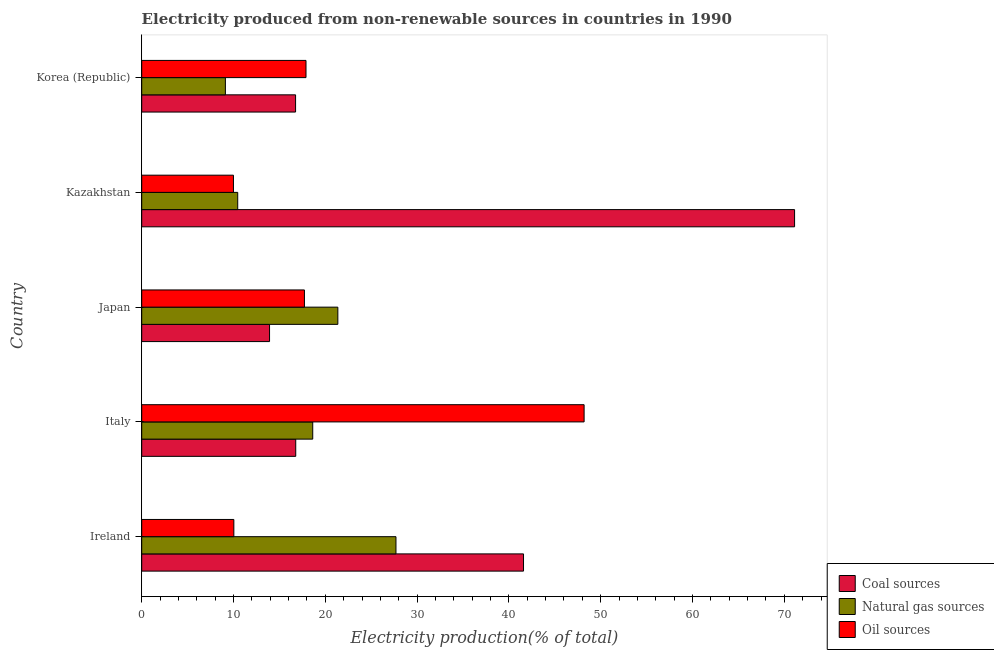How many bars are there on the 5th tick from the top?
Provide a succinct answer. 3. In how many cases, is the number of bars for a given country not equal to the number of legend labels?
Keep it short and to the point. 0. What is the percentage of electricity produced by oil sources in Korea (Republic)?
Offer a very short reply. 17.9. Across all countries, what is the maximum percentage of electricity produced by oil sources?
Your answer should be compact. 48.19. Across all countries, what is the minimum percentage of electricity produced by coal?
Your answer should be very brief. 13.92. In which country was the percentage of electricity produced by coal maximum?
Offer a terse response. Kazakhstan. What is the total percentage of electricity produced by natural gas in the graph?
Give a very brief answer. 87.26. What is the difference between the percentage of electricity produced by oil sources in Italy and that in Korea (Republic)?
Ensure brevity in your answer.  30.3. What is the difference between the percentage of electricity produced by natural gas in Japan and the percentage of electricity produced by coal in Italy?
Ensure brevity in your answer.  4.59. What is the average percentage of electricity produced by coal per country?
Make the answer very short. 32.03. What is the difference between the percentage of electricity produced by coal and percentage of electricity produced by natural gas in Ireland?
Offer a terse response. 13.89. Is the difference between the percentage of electricity produced by natural gas in Japan and Korea (Republic) greater than the difference between the percentage of electricity produced by coal in Japan and Korea (Republic)?
Provide a short and direct response. Yes. What is the difference between the highest and the second highest percentage of electricity produced by coal?
Make the answer very short. 29.53. What is the difference between the highest and the lowest percentage of electricity produced by natural gas?
Ensure brevity in your answer.  18.58. In how many countries, is the percentage of electricity produced by oil sources greater than the average percentage of electricity produced by oil sources taken over all countries?
Offer a terse response. 1. What does the 1st bar from the top in Kazakhstan represents?
Keep it short and to the point. Oil sources. What does the 2nd bar from the bottom in Italy represents?
Make the answer very short. Natural gas sources. What is the difference between two consecutive major ticks on the X-axis?
Make the answer very short. 10. Are the values on the major ticks of X-axis written in scientific E-notation?
Give a very brief answer. No. Where does the legend appear in the graph?
Your response must be concise. Bottom right. How many legend labels are there?
Your response must be concise. 3. What is the title of the graph?
Ensure brevity in your answer.  Electricity produced from non-renewable sources in countries in 1990. Does "Taxes on income" appear as one of the legend labels in the graph?
Your answer should be compact. No. What is the Electricity production(% of total) of Coal sources in Ireland?
Give a very brief answer. 41.59. What is the Electricity production(% of total) in Natural gas sources in Ireland?
Offer a very short reply. 27.7. What is the Electricity production(% of total) in Oil sources in Ireland?
Offer a terse response. 10.04. What is the Electricity production(% of total) of Coal sources in Italy?
Your answer should be compact. 16.78. What is the Electricity production(% of total) in Natural gas sources in Italy?
Your answer should be very brief. 18.63. What is the Electricity production(% of total) of Oil sources in Italy?
Your answer should be compact. 48.19. What is the Electricity production(% of total) in Coal sources in Japan?
Give a very brief answer. 13.92. What is the Electricity production(% of total) in Natural gas sources in Japan?
Provide a succinct answer. 21.36. What is the Electricity production(% of total) of Oil sources in Japan?
Your answer should be compact. 17.72. What is the Electricity production(% of total) in Coal sources in Kazakhstan?
Offer a terse response. 71.12. What is the Electricity production(% of total) in Natural gas sources in Kazakhstan?
Your answer should be very brief. 10.46. What is the Electricity production(% of total) in Oil sources in Kazakhstan?
Your answer should be very brief. 9.99. What is the Electricity production(% of total) in Coal sources in Korea (Republic)?
Your response must be concise. 16.76. What is the Electricity production(% of total) in Natural gas sources in Korea (Republic)?
Offer a terse response. 9.11. What is the Electricity production(% of total) in Oil sources in Korea (Republic)?
Provide a short and direct response. 17.9. Across all countries, what is the maximum Electricity production(% of total) of Coal sources?
Your answer should be very brief. 71.12. Across all countries, what is the maximum Electricity production(% of total) in Natural gas sources?
Offer a terse response. 27.7. Across all countries, what is the maximum Electricity production(% of total) of Oil sources?
Make the answer very short. 48.19. Across all countries, what is the minimum Electricity production(% of total) of Coal sources?
Provide a succinct answer. 13.92. Across all countries, what is the minimum Electricity production(% of total) in Natural gas sources?
Offer a terse response. 9.11. Across all countries, what is the minimum Electricity production(% of total) in Oil sources?
Provide a short and direct response. 9.99. What is the total Electricity production(% of total) in Coal sources in the graph?
Provide a short and direct response. 160.17. What is the total Electricity production(% of total) in Natural gas sources in the graph?
Your answer should be very brief. 87.26. What is the total Electricity production(% of total) in Oil sources in the graph?
Provide a succinct answer. 103.84. What is the difference between the Electricity production(% of total) in Coal sources in Ireland and that in Italy?
Keep it short and to the point. 24.81. What is the difference between the Electricity production(% of total) in Natural gas sources in Ireland and that in Italy?
Your response must be concise. 9.07. What is the difference between the Electricity production(% of total) of Oil sources in Ireland and that in Italy?
Keep it short and to the point. -38.16. What is the difference between the Electricity production(% of total) of Coal sources in Ireland and that in Japan?
Your answer should be compact. 27.67. What is the difference between the Electricity production(% of total) in Natural gas sources in Ireland and that in Japan?
Offer a terse response. 6.33. What is the difference between the Electricity production(% of total) of Oil sources in Ireland and that in Japan?
Your answer should be compact. -7.69. What is the difference between the Electricity production(% of total) in Coal sources in Ireland and that in Kazakhstan?
Keep it short and to the point. -29.53. What is the difference between the Electricity production(% of total) of Natural gas sources in Ireland and that in Kazakhstan?
Make the answer very short. 17.24. What is the difference between the Electricity production(% of total) in Oil sources in Ireland and that in Kazakhstan?
Make the answer very short. 0.04. What is the difference between the Electricity production(% of total) of Coal sources in Ireland and that in Korea (Republic)?
Make the answer very short. 24.83. What is the difference between the Electricity production(% of total) in Natural gas sources in Ireland and that in Korea (Republic)?
Keep it short and to the point. 18.58. What is the difference between the Electricity production(% of total) in Oil sources in Ireland and that in Korea (Republic)?
Make the answer very short. -7.86. What is the difference between the Electricity production(% of total) of Coal sources in Italy and that in Japan?
Keep it short and to the point. 2.85. What is the difference between the Electricity production(% of total) in Natural gas sources in Italy and that in Japan?
Provide a short and direct response. -2.73. What is the difference between the Electricity production(% of total) of Oil sources in Italy and that in Japan?
Ensure brevity in your answer.  30.47. What is the difference between the Electricity production(% of total) in Coal sources in Italy and that in Kazakhstan?
Your answer should be compact. -54.34. What is the difference between the Electricity production(% of total) in Natural gas sources in Italy and that in Kazakhstan?
Give a very brief answer. 8.17. What is the difference between the Electricity production(% of total) of Oil sources in Italy and that in Kazakhstan?
Provide a succinct answer. 38.2. What is the difference between the Electricity production(% of total) of Coal sources in Italy and that in Korea (Republic)?
Your response must be concise. 0.02. What is the difference between the Electricity production(% of total) in Natural gas sources in Italy and that in Korea (Republic)?
Your answer should be very brief. 9.52. What is the difference between the Electricity production(% of total) of Oil sources in Italy and that in Korea (Republic)?
Offer a terse response. 30.3. What is the difference between the Electricity production(% of total) in Coal sources in Japan and that in Kazakhstan?
Offer a terse response. -57.2. What is the difference between the Electricity production(% of total) of Natural gas sources in Japan and that in Kazakhstan?
Offer a terse response. 10.91. What is the difference between the Electricity production(% of total) of Oil sources in Japan and that in Kazakhstan?
Keep it short and to the point. 7.73. What is the difference between the Electricity production(% of total) of Coal sources in Japan and that in Korea (Republic)?
Give a very brief answer. -2.84. What is the difference between the Electricity production(% of total) of Natural gas sources in Japan and that in Korea (Republic)?
Keep it short and to the point. 12.25. What is the difference between the Electricity production(% of total) in Oil sources in Japan and that in Korea (Republic)?
Make the answer very short. -0.17. What is the difference between the Electricity production(% of total) of Coal sources in Kazakhstan and that in Korea (Republic)?
Provide a short and direct response. 54.36. What is the difference between the Electricity production(% of total) of Natural gas sources in Kazakhstan and that in Korea (Republic)?
Your answer should be very brief. 1.34. What is the difference between the Electricity production(% of total) in Oil sources in Kazakhstan and that in Korea (Republic)?
Provide a succinct answer. -7.9. What is the difference between the Electricity production(% of total) in Coal sources in Ireland and the Electricity production(% of total) in Natural gas sources in Italy?
Your answer should be very brief. 22.96. What is the difference between the Electricity production(% of total) of Coal sources in Ireland and the Electricity production(% of total) of Oil sources in Italy?
Make the answer very short. -6.6. What is the difference between the Electricity production(% of total) in Natural gas sources in Ireland and the Electricity production(% of total) in Oil sources in Italy?
Offer a very short reply. -20.49. What is the difference between the Electricity production(% of total) in Coal sources in Ireland and the Electricity production(% of total) in Natural gas sources in Japan?
Offer a terse response. 20.23. What is the difference between the Electricity production(% of total) in Coal sources in Ireland and the Electricity production(% of total) in Oil sources in Japan?
Your answer should be very brief. 23.87. What is the difference between the Electricity production(% of total) in Natural gas sources in Ireland and the Electricity production(% of total) in Oil sources in Japan?
Offer a terse response. 9.97. What is the difference between the Electricity production(% of total) of Coal sources in Ireland and the Electricity production(% of total) of Natural gas sources in Kazakhstan?
Keep it short and to the point. 31.13. What is the difference between the Electricity production(% of total) in Coal sources in Ireland and the Electricity production(% of total) in Oil sources in Kazakhstan?
Ensure brevity in your answer.  31.6. What is the difference between the Electricity production(% of total) in Natural gas sources in Ireland and the Electricity production(% of total) in Oil sources in Kazakhstan?
Offer a terse response. 17.7. What is the difference between the Electricity production(% of total) of Coal sources in Ireland and the Electricity production(% of total) of Natural gas sources in Korea (Republic)?
Provide a short and direct response. 32.48. What is the difference between the Electricity production(% of total) of Coal sources in Ireland and the Electricity production(% of total) of Oil sources in Korea (Republic)?
Make the answer very short. 23.7. What is the difference between the Electricity production(% of total) of Natural gas sources in Ireland and the Electricity production(% of total) of Oil sources in Korea (Republic)?
Your response must be concise. 9.8. What is the difference between the Electricity production(% of total) of Coal sources in Italy and the Electricity production(% of total) of Natural gas sources in Japan?
Make the answer very short. -4.59. What is the difference between the Electricity production(% of total) in Coal sources in Italy and the Electricity production(% of total) in Oil sources in Japan?
Your answer should be compact. -0.95. What is the difference between the Electricity production(% of total) of Natural gas sources in Italy and the Electricity production(% of total) of Oil sources in Japan?
Your answer should be compact. 0.91. What is the difference between the Electricity production(% of total) of Coal sources in Italy and the Electricity production(% of total) of Natural gas sources in Kazakhstan?
Your answer should be very brief. 6.32. What is the difference between the Electricity production(% of total) of Coal sources in Italy and the Electricity production(% of total) of Oil sources in Kazakhstan?
Ensure brevity in your answer.  6.79. What is the difference between the Electricity production(% of total) in Natural gas sources in Italy and the Electricity production(% of total) in Oil sources in Kazakhstan?
Your answer should be compact. 8.64. What is the difference between the Electricity production(% of total) in Coal sources in Italy and the Electricity production(% of total) in Natural gas sources in Korea (Republic)?
Give a very brief answer. 7.66. What is the difference between the Electricity production(% of total) of Coal sources in Italy and the Electricity production(% of total) of Oil sources in Korea (Republic)?
Your answer should be very brief. -1.12. What is the difference between the Electricity production(% of total) of Natural gas sources in Italy and the Electricity production(% of total) of Oil sources in Korea (Republic)?
Offer a very short reply. 0.73. What is the difference between the Electricity production(% of total) in Coal sources in Japan and the Electricity production(% of total) in Natural gas sources in Kazakhstan?
Your response must be concise. 3.47. What is the difference between the Electricity production(% of total) in Coal sources in Japan and the Electricity production(% of total) in Oil sources in Kazakhstan?
Give a very brief answer. 3.93. What is the difference between the Electricity production(% of total) in Natural gas sources in Japan and the Electricity production(% of total) in Oil sources in Kazakhstan?
Provide a succinct answer. 11.37. What is the difference between the Electricity production(% of total) of Coal sources in Japan and the Electricity production(% of total) of Natural gas sources in Korea (Republic)?
Provide a succinct answer. 4.81. What is the difference between the Electricity production(% of total) of Coal sources in Japan and the Electricity production(% of total) of Oil sources in Korea (Republic)?
Your answer should be very brief. -3.97. What is the difference between the Electricity production(% of total) in Natural gas sources in Japan and the Electricity production(% of total) in Oil sources in Korea (Republic)?
Give a very brief answer. 3.47. What is the difference between the Electricity production(% of total) of Coal sources in Kazakhstan and the Electricity production(% of total) of Natural gas sources in Korea (Republic)?
Offer a terse response. 62.01. What is the difference between the Electricity production(% of total) in Coal sources in Kazakhstan and the Electricity production(% of total) in Oil sources in Korea (Republic)?
Keep it short and to the point. 53.22. What is the difference between the Electricity production(% of total) of Natural gas sources in Kazakhstan and the Electricity production(% of total) of Oil sources in Korea (Republic)?
Keep it short and to the point. -7.44. What is the average Electricity production(% of total) of Coal sources per country?
Provide a short and direct response. 32.03. What is the average Electricity production(% of total) in Natural gas sources per country?
Make the answer very short. 17.45. What is the average Electricity production(% of total) of Oil sources per country?
Offer a terse response. 20.77. What is the difference between the Electricity production(% of total) of Coal sources and Electricity production(% of total) of Natural gas sources in Ireland?
Provide a succinct answer. 13.89. What is the difference between the Electricity production(% of total) in Coal sources and Electricity production(% of total) in Oil sources in Ireland?
Provide a short and direct response. 31.56. What is the difference between the Electricity production(% of total) of Natural gas sources and Electricity production(% of total) of Oil sources in Ireland?
Your answer should be compact. 17.66. What is the difference between the Electricity production(% of total) of Coal sources and Electricity production(% of total) of Natural gas sources in Italy?
Keep it short and to the point. -1.85. What is the difference between the Electricity production(% of total) in Coal sources and Electricity production(% of total) in Oil sources in Italy?
Provide a succinct answer. -31.41. What is the difference between the Electricity production(% of total) in Natural gas sources and Electricity production(% of total) in Oil sources in Italy?
Offer a very short reply. -29.56. What is the difference between the Electricity production(% of total) in Coal sources and Electricity production(% of total) in Natural gas sources in Japan?
Offer a very short reply. -7.44. What is the difference between the Electricity production(% of total) of Coal sources and Electricity production(% of total) of Oil sources in Japan?
Your response must be concise. -3.8. What is the difference between the Electricity production(% of total) in Natural gas sources and Electricity production(% of total) in Oil sources in Japan?
Provide a short and direct response. 3.64. What is the difference between the Electricity production(% of total) of Coal sources and Electricity production(% of total) of Natural gas sources in Kazakhstan?
Your answer should be compact. 60.66. What is the difference between the Electricity production(% of total) in Coal sources and Electricity production(% of total) in Oil sources in Kazakhstan?
Your response must be concise. 61.13. What is the difference between the Electricity production(% of total) in Natural gas sources and Electricity production(% of total) in Oil sources in Kazakhstan?
Keep it short and to the point. 0.47. What is the difference between the Electricity production(% of total) of Coal sources and Electricity production(% of total) of Natural gas sources in Korea (Republic)?
Your answer should be compact. 7.65. What is the difference between the Electricity production(% of total) in Coal sources and Electricity production(% of total) in Oil sources in Korea (Republic)?
Make the answer very short. -1.14. What is the difference between the Electricity production(% of total) of Natural gas sources and Electricity production(% of total) of Oil sources in Korea (Republic)?
Provide a short and direct response. -8.78. What is the ratio of the Electricity production(% of total) in Coal sources in Ireland to that in Italy?
Your answer should be compact. 2.48. What is the ratio of the Electricity production(% of total) in Natural gas sources in Ireland to that in Italy?
Make the answer very short. 1.49. What is the ratio of the Electricity production(% of total) of Oil sources in Ireland to that in Italy?
Your response must be concise. 0.21. What is the ratio of the Electricity production(% of total) of Coal sources in Ireland to that in Japan?
Make the answer very short. 2.99. What is the ratio of the Electricity production(% of total) in Natural gas sources in Ireland to that in Japan?
Keep it short and to the point. 1.3. What is the ratio of the Electricity production(% of total) in Oil sources in Ireland to that in Japan?
Your answer should be very brief. 0.57. What is the ratio of the Electricity production(% of total) in Coal sources in Ireland to that in Kazakhstan?
Your answer should be very brief. 0.58. What is the ratio of the Electricity production(% of total) of Natural gas sources in Ireland to that in Kazakhstan?
Your answer should be very brief. 2.65. What is the ratio of the Electricity production(% of total) of Oil sources in Ireland to that in Kazakhstan?
Your answer should be compact. 1. What is the ratio of the Electricity production(% of total) in Coal sources in Ireland to that in Korea (Republic)?
Ensure brevity in your answer.  2.48. What is the ratio of the Electricity production(% of total) in Natural gas sources in Ireland to that in Korea (Republic)?
Provide a short and direct response. 3.04. What is the ratio of the Electricity production(% of total) in Oil sources in Ireland to that in Korea (Republic)?
Provide a succinct answer. 0.56. What is the ratio of the Electricity production(% of total) in Coal sources in Italy to that in Japan?
Offer a very short reply. 1.2. What is the ratio of the Electricity production(% of total) in Natural gas sources in Italy to that in Japan?
Make the answer very short. 0.87. What is the ratio of the Electricity production(% of total) in Oil sources in Italy to that in Japan?
Your response must be concise. 2.72. What is the ratio of the Electricity production(% of total) of Coal sources in Italy to that in Kazakhstan?
Keep it short and to the point. 0.24. What is the ratio of the Electricity production(% of total) of Natural gas sources in Italy to that in Kazakhstan?
Your answer should be very brief. 1.78. What is the ratio of the Electricity production(% of total) of Oil sources in Italy to that in Kazakhstan?
Ensure brevity in your answer.  4.82. What is the ratio of the Electricity production(% of total) in Coal sources in Italy to that in Korea (Republic)?
Give a very brief answer. 1. What is the ratio of the Electricity production(% of total) in Natural gas sources in Italy to that in Korea (Republic)?
Your response must be concise. 2.04. What is the ratio of the Electricity production(% of total) of Oil sources in Italy to that in Korea (Republic)?
Make the answer very short. 2.69. What is the ratio of the Electricity production(% of total) in Coal sources in Japan to that in Kazakhstan?
Ensure brevity in your answer.  0.2. What is the ratio of the Electricity production(% of total) in Natural gas sources in Japan to that in Kazakhstan?
Make the answer very short. 2.04. What is the ratio of the Electricity production(% of total) of Oil sources in Japan to that in Kazakhstan?
Offer a very short reply. 1.77. What is the ratio of the Electricity production(% of total) of Coal sources in Japan to that in Korea (Republic)?
Your response must be concise. 0.83. What is the ratio of the Electricity production(% of total) of Natural gas sources in Japan to that in Korea (Republic)?
Offer a very short reply. 2.34. What is the ratio of the Electricity production(% of total) of Coal sources in Kazakhstan to that in Korea (Republic)?
Offer a very short reply. 4.24. What is the ratio of the Electricity production(% of total) in Natural gas sources in Kazakhstan to that in Korea (Republic)?
Provide a succinct answer. 1.15. What is the ratio of the Electricity production(% of total) in Oil sources in Kazakhstan to that in Korea (Republic)?
Your answer should be very brief. 0.56. What is the difference between the highest and the second highest Electricity production(% of total) in Coal sources?
Keep it short and to the point. 29.53. What is the difference between the highest and the second highest Electricity production(% of total) of Natural gas sources?
Give a very brief answer. 6.33. What is the difference between the highest and the second highest Electricity production(% of total) of Oil sources?
Ensure brevity in your answer.  30.3. What is the difference between the highest and the lowest Electricity production(% of total) of Coal sources?
Your answer should be compact. 57.2. What is the difference between the highest and the lowest Electricity production(% of total) in Natural gas sources?
Make the answer very short. 18.58. What is the difference between the highest and the lowest Electricity production(% of total) of Oil sources?
Offer a very short reply. 38.2. 